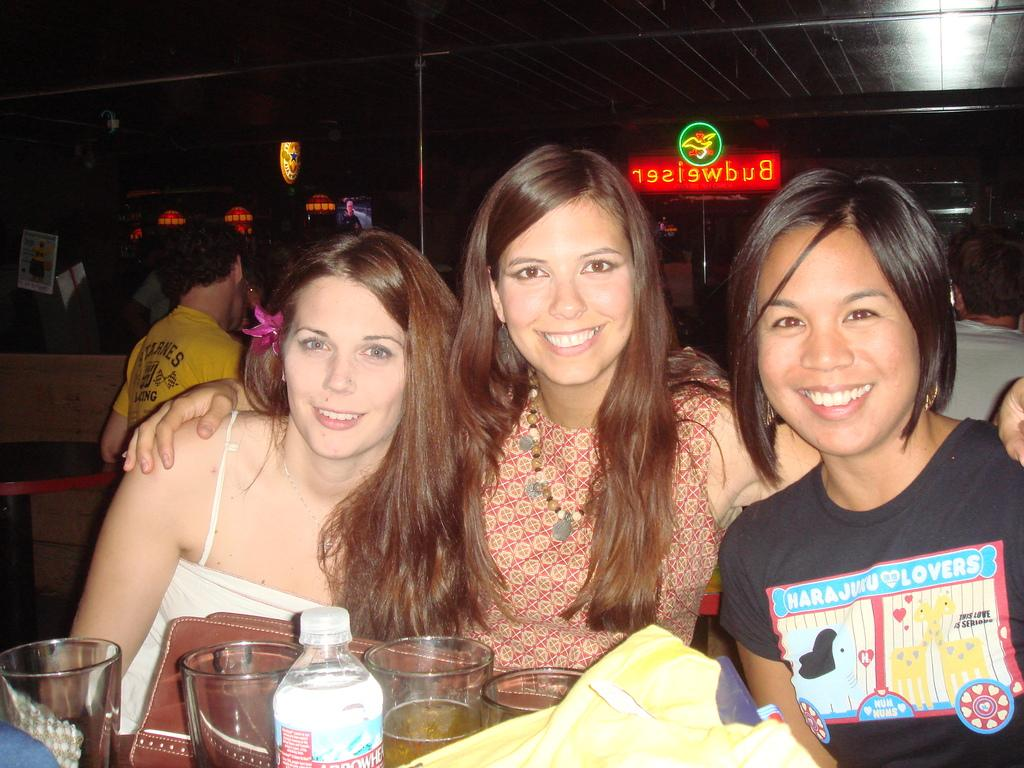How many women are sitting together in the image? There are three women sitting next to each other in the image. What is happening in the background of the image? There are people standing in the background of the image, and a board and roof are also visible. Can you describe the seating arrangement of the women? The three women are sitting next to each other. What type of plants does the dad in the image have in his garden? There is no dad or garden mentioned in the image, so it is not possible to answer that question. 